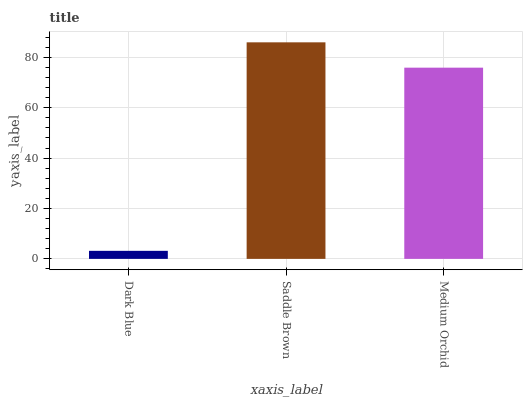Is Medium Orchid the minimum?
Answer yes or no. No. Is Medium Orchid the maximum?
Answer yes or no. No. Is Saddle Brown greater than Medium Orchid?
Answer yes or no. Yes. Is Medium Orchid less than Saddle Brown?
Answer yes or no. Yes. Is Medium Orchid greater than Saddle Brown?
Answer yes or no. No. Is Saddle Brown less than Medium Orchid?
Answer yes or no. No. Is Medium Orchid the high median?
Answer yes or no. Yes. Is Medium Orchid the low median?
Answer yes or no. Yes. Is Dark Blue the high median?
Answer yes or no. No. Is Dark Blue the low median?
Answer yes or no. No. 